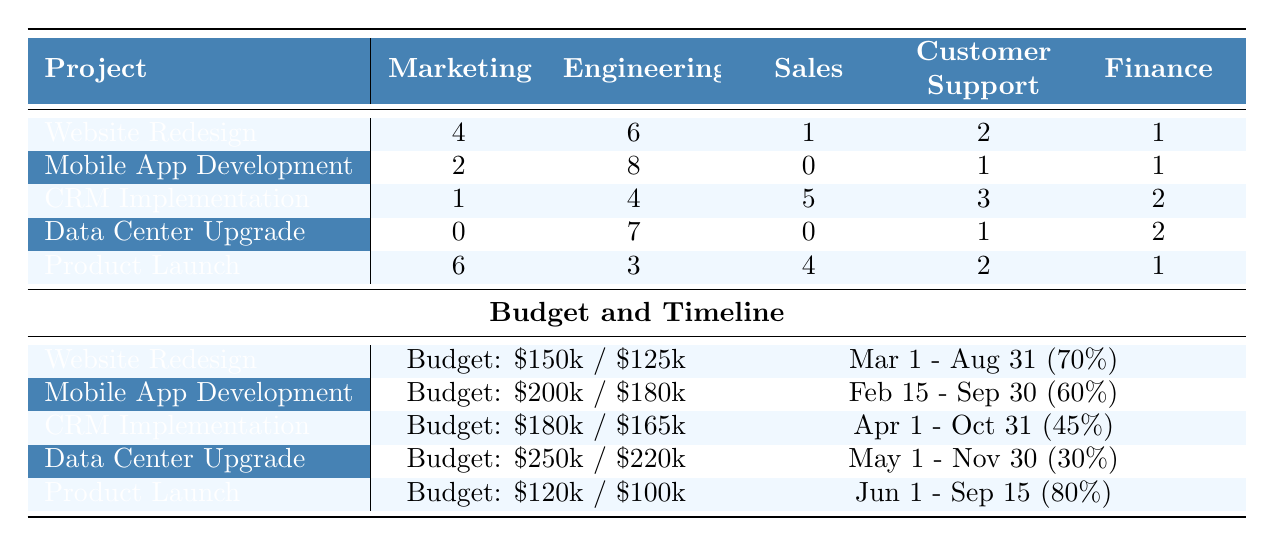What is the allocated budget for the Mobile App Development project? Referring to the budget section of the table, the allocated budget for the Mobile App Development project is listed as $200,000.
Answer: $200,000 How many resources are allocated to the Engineering department for the Data Center Upgrade project? Looking at the resource allocation for the Data Center Upgrade project, the Engineering department has 7 resources allocated to it.
Answer: 7 Which project has the highest number of resources allocated to Customer Support? By examining the resources allocated to Customer Support across all projects, the CRM Implementation project has 3 resources, which is the highest among all listed projects.
Answer: CRM Implementation What is the total number of resources allocated to the Marketing department across all projects? Adding the Marketing resources from each project: 4 (Website Redesign) + 2 (Mobile App Development) + 1 (CRM Implementation) + 0 (Data Center Upgrade) + 6 (Product Launch) = 13.
Answer: 13 Is the used budget for the Product Launch project less than the used budget for the Website Redesign project? Checking the used budgets, the Product Launch has used $100,000 while the Website Redesign has used $125,000. Since $100,000 is less than $125,000, the statement is true.
Answer: Yes What is the difference in utilized budget between the Data Center Upgrade and the CRM Implementation projects? The utilized budget for Data Center Upgrade is $220,000 and for CRM Implementation, it is $165,000. Calculating the difference: $220,000 - $165,000 = $55,000.
Answer: $55,000 Which project has the lowest progress percentage and what is that percentage? By reviewing the progress percentages, the Data Center Upgrade project has the lowest progress at 30%.
Answer: 30% If we sum all resources allocated to Sales across all projects, what is the total? Adding the Sales resources: 1 (Website Redesign) + 0 (Mobile App Development) + 5 (CRM Implementation) + 0 (Data Center Upgrade) + 4 (Product Launch) equals 10.
Answer: 10 Do any projects have an allocated budget exceeding $200,000? By checking the allocated budget for each project, only the Data Center Upgrade has an allocated budget of $250,000, which exceeds $200,000, while the others do not. Thus, the answer is yes.
Answer: Yes What is the ratio of the allocated budget to the used budget for the Mobile App Development project? The allocated budget is $200,000 and the used budget is $180,000. The ratio is calculated as $200,000 : $180,000, which simplifies to 10:9.
Answer: 10:9 